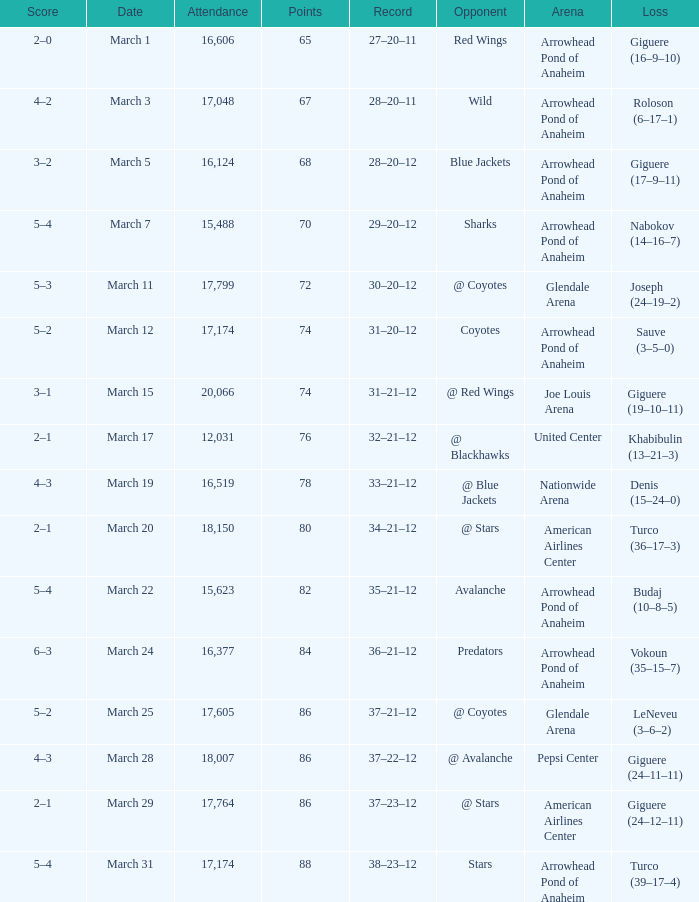What is the Loss of the game at Nationwide Arena with a Score of 4–3? Denis (15–24–0). 